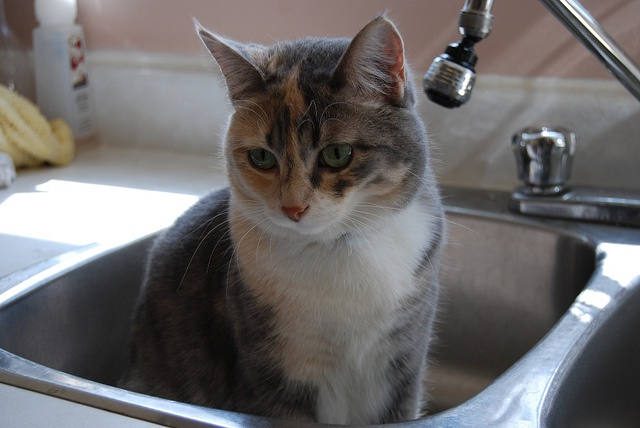Describe the objects in this image and their specific colors. I can see cat in gray, black, and darkgray tones, sink in gray, black, white, and darkgray tones, and bottle in gray and darkgray tones in this image. 